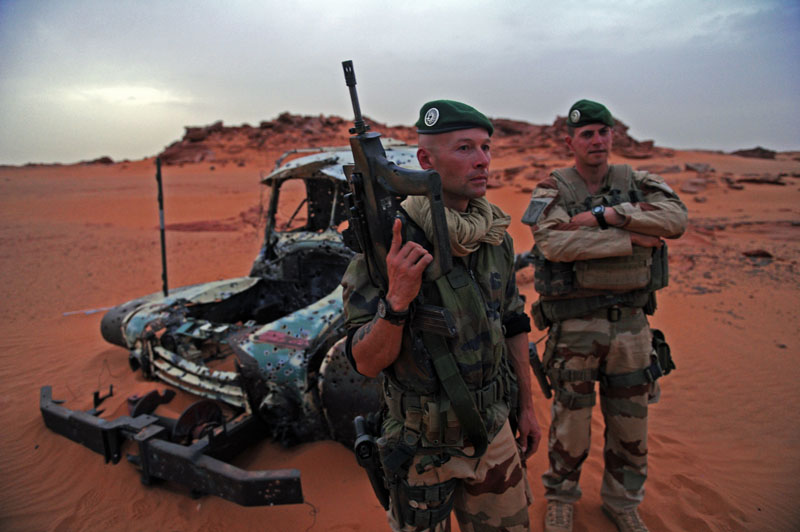The soldiers find an ancient artifact buried in the sands. What might their response be, and how could this discovery affect their mission? Finding an ancient artifact could significantly affect the soldiers' mission. Initially, their response would likely be one of curiosity and heightened alertness, as they evaluate the artifact's significance and any potential threats or opportunities associated with it. They might secure the area and report their discovery to their higher command for further instructions. Depending on the nature of their mission, the artifact could lead to a redirection of focus - perhaps calling in experts to investigate the find, or even marking the area for further study after their primary mission is completed. This discovery could also offer strategic advantages, such as historical insights into the terrain or attracting interest and assistance from other parties. However, it could also complicate their mission by introducing new objectives or distractions. What if the artifact has mystical properties? If the artifact is believed to have mystical properties, it could introduce an element of unpredictability and fascination among the soldiers. They might experience a mix of skepticism and intrigue, being careful in handling and interpreting the artifact. This situation could potentially alter their mission dynamics, as the artifact might provide unexpected advantages or challenges depending on its properties. There might be a heightened sense of speculation and discussion within the group, influencing their morale and decision-making processes. Additionally, they would likely report this development promptly, potentially diverting their mission focus towards understanding and utilizing the artifact safely and effectively. 